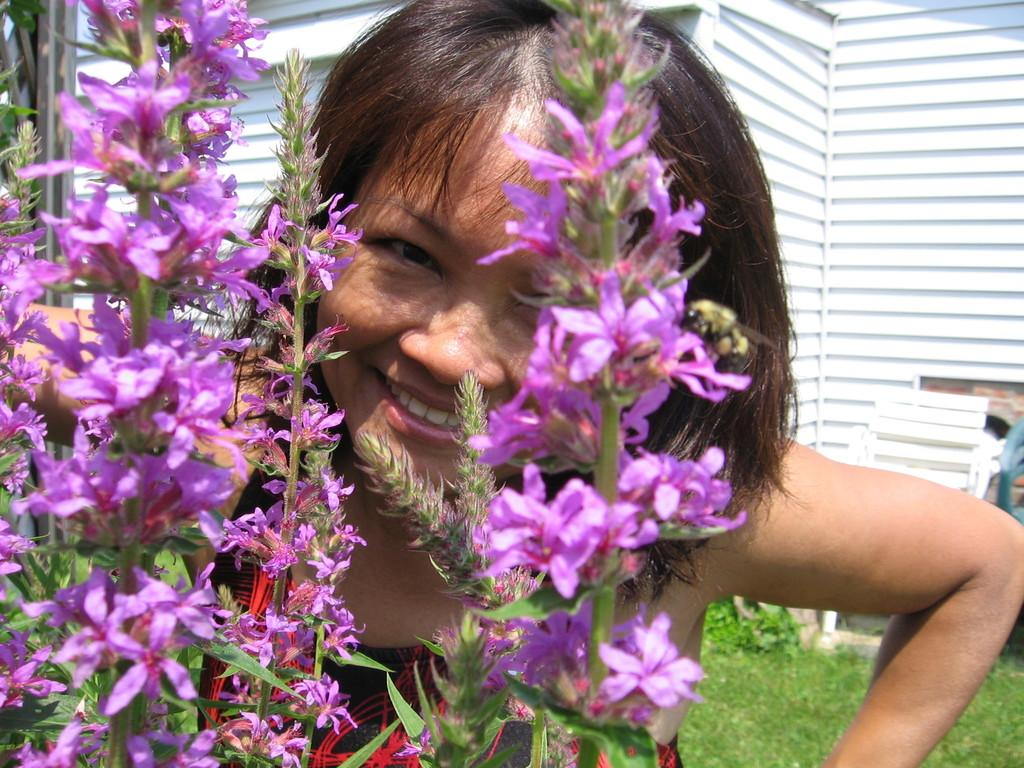What type of plants can be seen in the image? There are flowers in the image. What other natural elements are present in the image? There is grass in the image. Who is in the image? There is a girl in the image. What is the girl's expression? The girl is smiling. What can be seen in the background of the image? There is a wall in the background of the image. What type of disease can be seen affecting the flowers in the image? There is no disease affecting the flowers in the image; they appear healthy. Can you tell me how many tigers are present in the image? There are no tigers present in the image; it features flowers, grass, and a girl. 